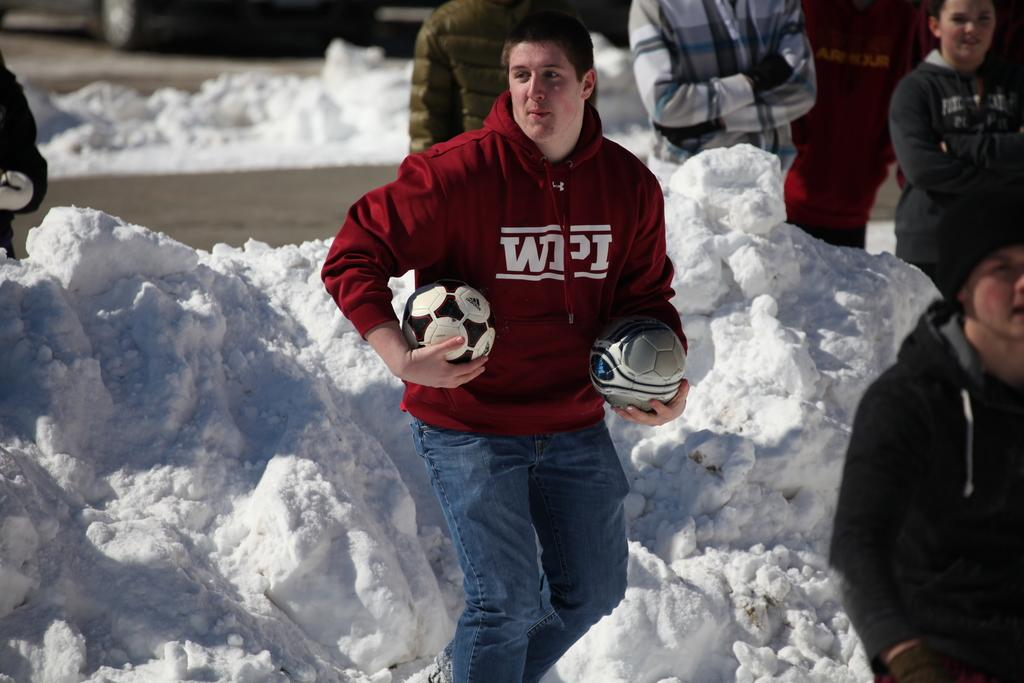What is the main subject of the image? There is a man standing in the image. What is the man holding in his hand? The man is holding two footballs in his hand. Can you describe the background of the image? The background appears to be snowy. Are there any other people visible in the image? Yes, there are people in the background of the image. What type of jewel is the man wearing on his top in the image? There is no mention of a jewel or any clothing item on the man's top in the image. 